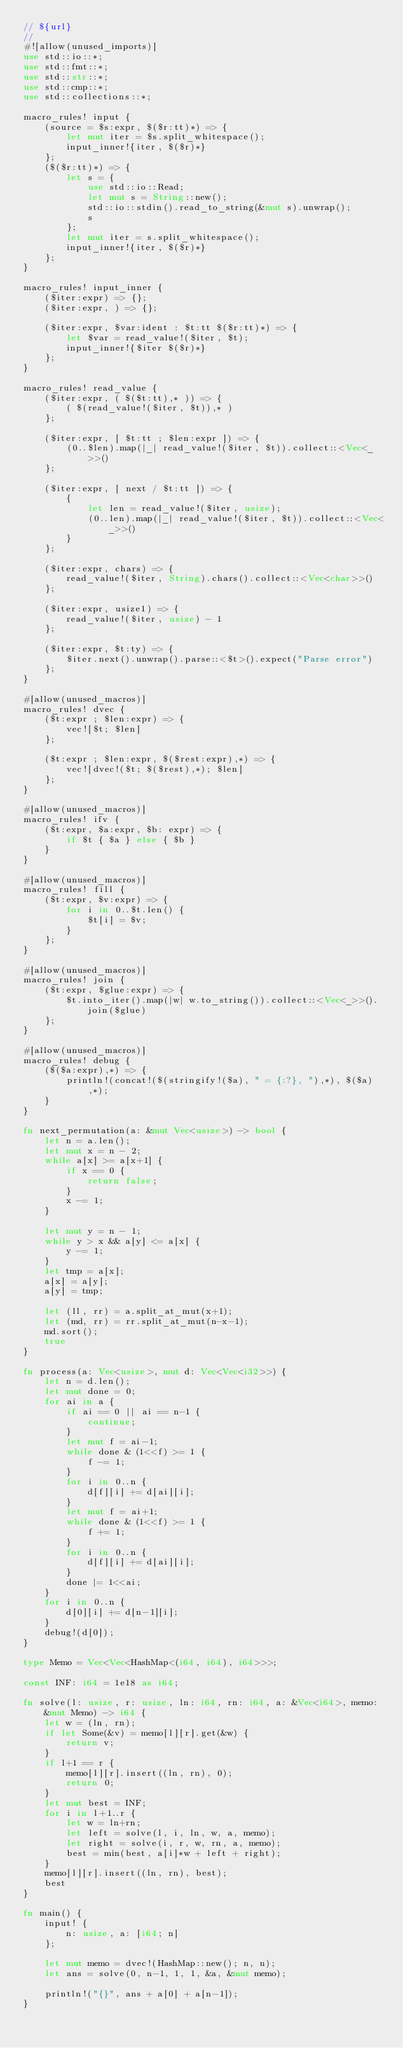<code> <loc_0><loc_0><loc_500><loc_500><_Rust_>// ${url}
//
#![allow(unused_imports)]
use std::io::*;
use std::fmt::*;
use std::str::*;
use std::cmp::*;
use std::collections::*;

macro_rules! input {
    (source = $s:expr, $($r:tt)*) => {
        let mut iter = $s.split_whitespace();
        input_inner!{iter, $($r)*}
    };
    ($($r:tt)*) => {
        let s = {
            use std::io::Read;
            let mut s = String::new();
            std::io::stdin().read_to_string(&mut s).unwrap();
            s
        };
        let mut iter = s.split_whitespace();
        input_inner!{iter, $($r)*}
    };
}

macro_rules! input_inner {
    ($iter:expr) => {};
    ($iter:expr, ) => {};

    ($iter:expr, $var:ident : $t:tt $($r:tt)*) => {
        let $var = read_value!($iter, $t);
        input_inner!{$iter $($r)*}
    };
}

macro_rules! read_value {
    ($iter:expr, ( $($t:tt),* )) => {
        ( $(read_value!($iter, $t)),* )
    };

    ($iter:expr, [ $t:tt ; $len:expr ]) => {
        (0..$len).map(|_| read_value!($iter, $t)).collect::<Vec<_>>()
    };

    ($iter:expr, [ next / $t:tt ]) => {
        {
            let len = read_value!($iter, usize);
            (0..len).map(|_| read_value!($iter, $t)).collect::<Vec<_>>()
        }
    };

    ($iter:expr, chars) => {
        read_value!($iter, String).chars().collect::<Vec<char>>()
    };

    ($iter:expr, usize1) => {
        read_value!($iter, usize) - 1
    };

    ($iter:expr, $t:ty) => {
        $iter.next().unwrap().parse::<$t>().expect("Parse error")
    };
}

#[allow(unused_macros)]
macro_rules! dvec {
    ($t:expr ; $len:expr) => {
        vec![$t; $len]
    };

    ($t:expr ; $len:expr, $($rest:expr),*) => {
        vec![dvec!($t; $($rest),*); $len]
    };
}

#[allow(unused_macros)]
macro_rules! ifv {
    ($t:expr, $a:expr, $b: expr) => {
        if $t { $a } else { $b }
    }
}

#[allow(unused_macros)]
macro_rules! fill {
    ($t:expr, $v:expr) => {
        for i in 0..$t.len() {
            $t[i] = $v;
        }
    };
}

#[allow(unused_macros)]
macro_rules! join {
    ($t:expr, $glue:expr) => {
        $t.into_iter().map(|w| w.to_string()).collect::<Vec<_>>().join($glue)
    };
}

#[allow(unused_macros)]
macro_rules! debug {
    ($($a:expr),*) => {
        println!(concat!($(stringify!($a), " = {:?}, "),*), $($a),*);
    }
}

fn next_permutation(a: &mut Vec<usize>) -> bool {
    let n = a.len();
    let mut x = n - 2;
    while a[x] >= a[x+1] {
        if x == 0 {
            return false;
        }
        x -= 1;
    }

    let mut y = n - 1;
    while y > x && a[y] <= a[x] {
        y -= 1;
    }
    let tmp = a[x];
    a[x] = a[y];
    a[y] = tmp;

    let (ll, rr) = a.split_at_mut(x+1);
    let (md, rr) = rr.split_at_mut(n-x-1);
    md.sort();
    true
}

fn process(a: Vec<usize>, mut d: Vec<Vec<i32>>) {
    let n = d.len();
    let mut done = 0;
    for ai in a {
        if ai == 0 || ai == n-1 {
            continue;
        }
        let mut f = ai-1;
        while done & (1<<f) >= 1 {
            f -= 1;
        }
        for i in 0..n {
            d[f][i] += d[ai][i];
        }
        let mut f = ai+1;
        while done & (1<<f) >= 1 {
            f += 1;
        }
        for i in 0..n {
            d[f][i] += d[ai][i];
        }
        done |= 1<<ai;
    }
    for i in 0..n {
        d[0][i] += d[n-1][i];
    }
    debug!(d[0]);
}

type Memo = Vec<Vec<HashMap<(i64, i64), i64>>>;

const INF: i64 = 1e18 as i64;

fn solve(l: usize, r: usize, ln: i64, rn: i64, a: &Vec<i64>, memo: &mut Memo) -> i64 {
    let w = (ln, rn);
    if let Some(&v) = memo[l][r].get(&w) {
        return v;
    }
    if l+1 == r {
        memo[l][r].insert((ln, rn), 0);
        return 0;
    }
    let mut best = INF;
    for i in l+1..r {
        let w = ln+rn;
        let left = solve(l, i, ln, w, a, memo);
        let right = solve(i, r, w, rn, a, memo);
        best = min(best, a[i]*w + left + right);
    }
    memo[l][r].insert((ln, rn), best);
    best
}

fn main() {
    input! {
        n: usize, a: [i64; n]
    };

    let mut memo = dvec!(HashMap::new(); n, n);
    let ans = solve(0, n-1, 1, 1, &a, &mut memo);

    println!("{}", ans + a[0] + a[n-1]);
}
</code> 